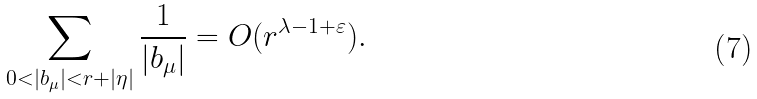Convert formula to latex. <formula><loc_0><loc_0><loc_500><loc_500>\sum _ { 0 < | b _ { \mu } | < r + | \eta | } \frac { 1 } { | b _ { \mu } | } = O ( r ^ { \lambda - 1 + \varepsilon } ) .</formula> 